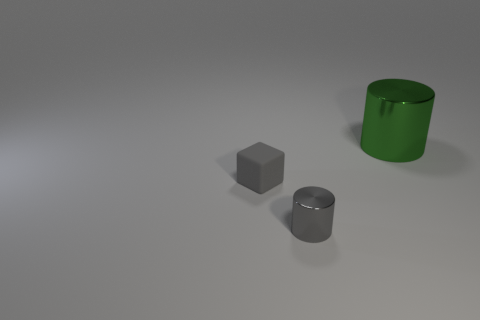Add 3 big cyan matte cubes. How many objects exist? 6 Subtract all blocks. How many objects are left? 2 Add 2 green cylinders. How many green cylinders are left? 3 Add 1 cylinders. How many cylinders exist? 3 Subtract 0 brown spheres. How many objects are left? 3 Subtract all large cylinders. Subtract all small rubber objects. How many objects are left? 1 